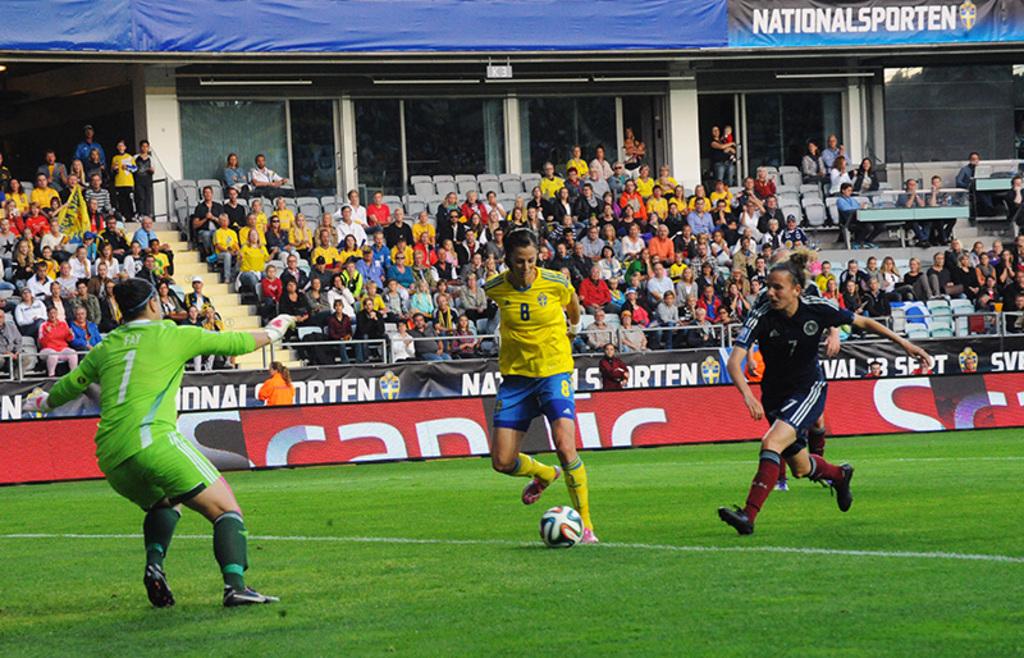What number is the light green player?
Your answer should be very brief. 1. 